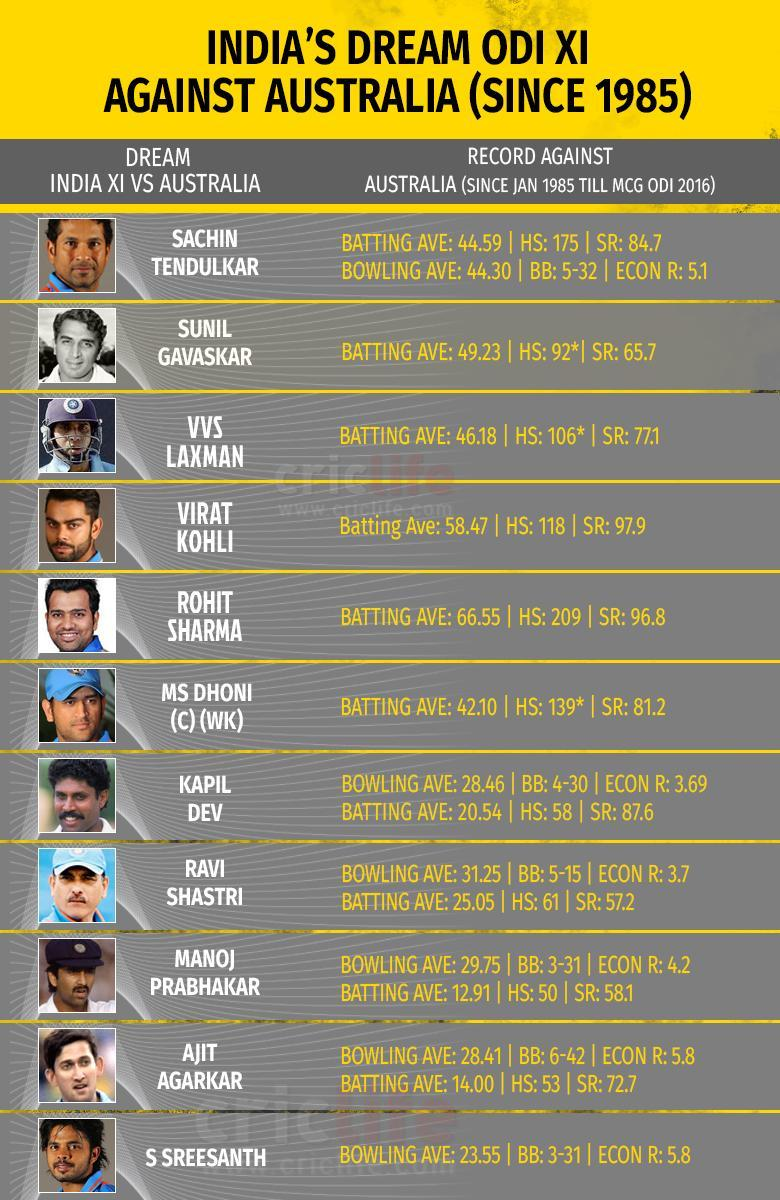Who scored the highest batting average against Australia in ODI?
Answer the question with a short phrase. Rohit Sharma Which was the lowest batting average scored in ODI against Australia? 12.91 What is the highest bowling average scored in ODI against Australia? 44.30 